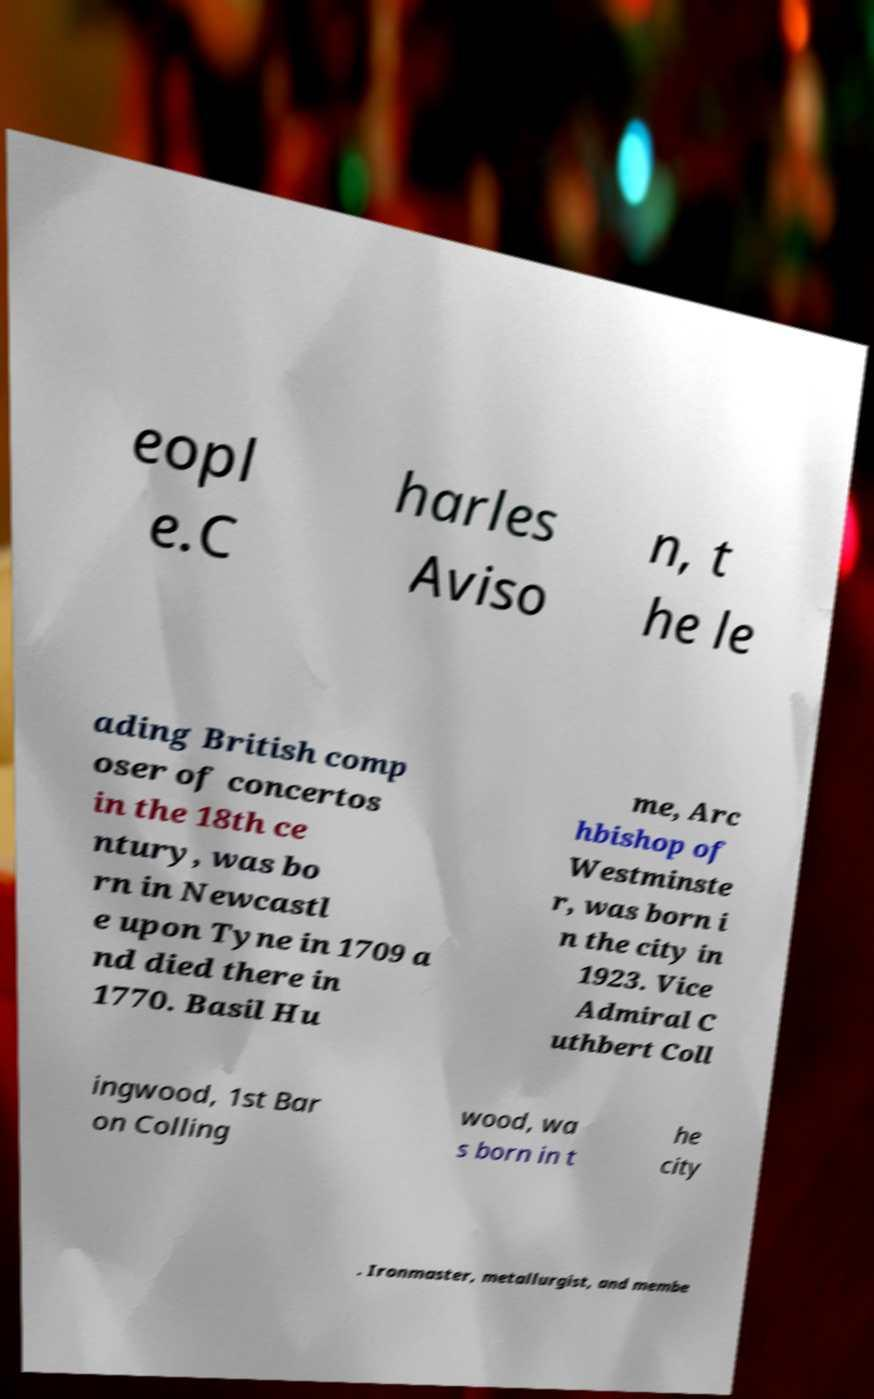I need the written content from this picture converted into text. Can you do that? eopl e.C harles Aviso n, t he le ading British comp oser of concertos in the 18th ce ntury, was bo rn in Newcastl e upon Tyne in 1709 a nd died there in 1770. Basil Hu me, Arc hbishop of Westminste r, was born i n the city in 1923. Vice Admiral C uthbert Coll ingwood, 1st Bar on Colling wood, wa s born in t he city . Ironmaster, metallurgist, and membe 